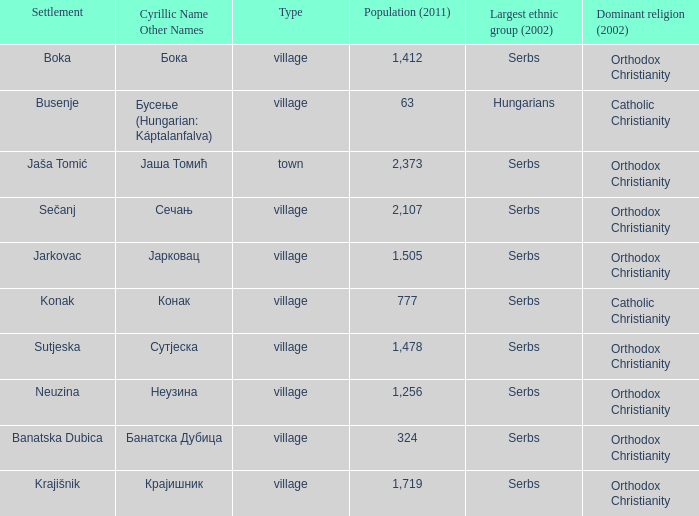The population is 2,107's dominant religion is? Orthodox Christianity. 